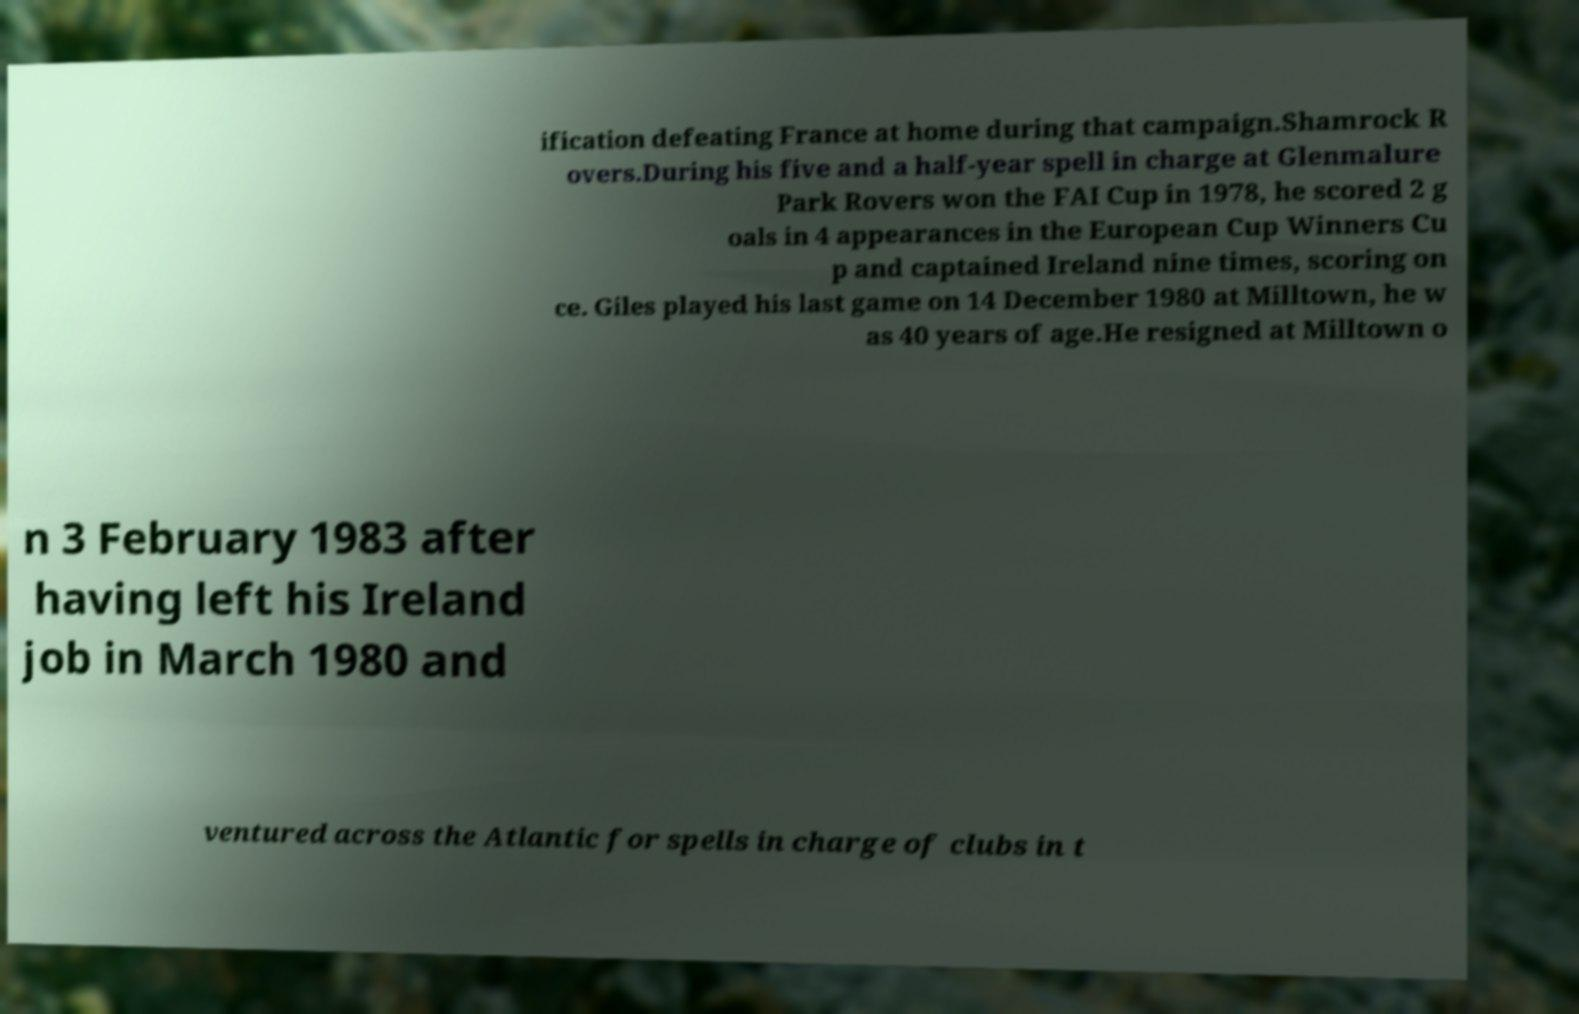Could you assist in decoding the text presented in this image and type it out clearly? ification defeating France at home during that campaign.Shamrock R overs.During his five and a half-year spell in charge at Glenmalure Park Rovers won the FAI Cup in 1978, he scored 2 g oals in 4 appearances in the European Cup Winners Cu p and captained Ireland nine times, scoring on ce. Giles played his last game on 14 December 1980 at Milltown, he w as 40 years of age.He resigned at Milltown o n 3 February 1983 after having left his Ireland job in March 1980 and ventured across the Atlantic for spells in charge of clubs in t 